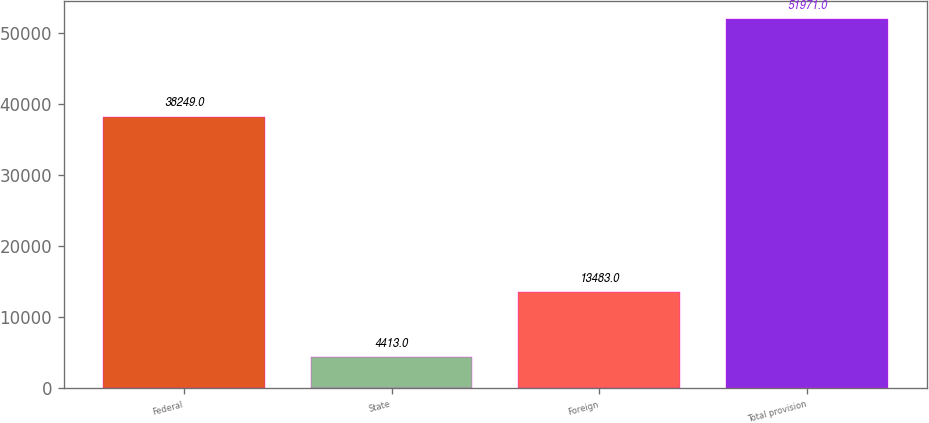<chart> <loc_0><loc_0><loc_500><loc_500><bar_chart><fcel>Federal<fcel>State<fcel>Foreign<fcel>Total provision<nl><fcel>38249<fcel>4413<fcel>13483<fcel>51971<nl></chart> 